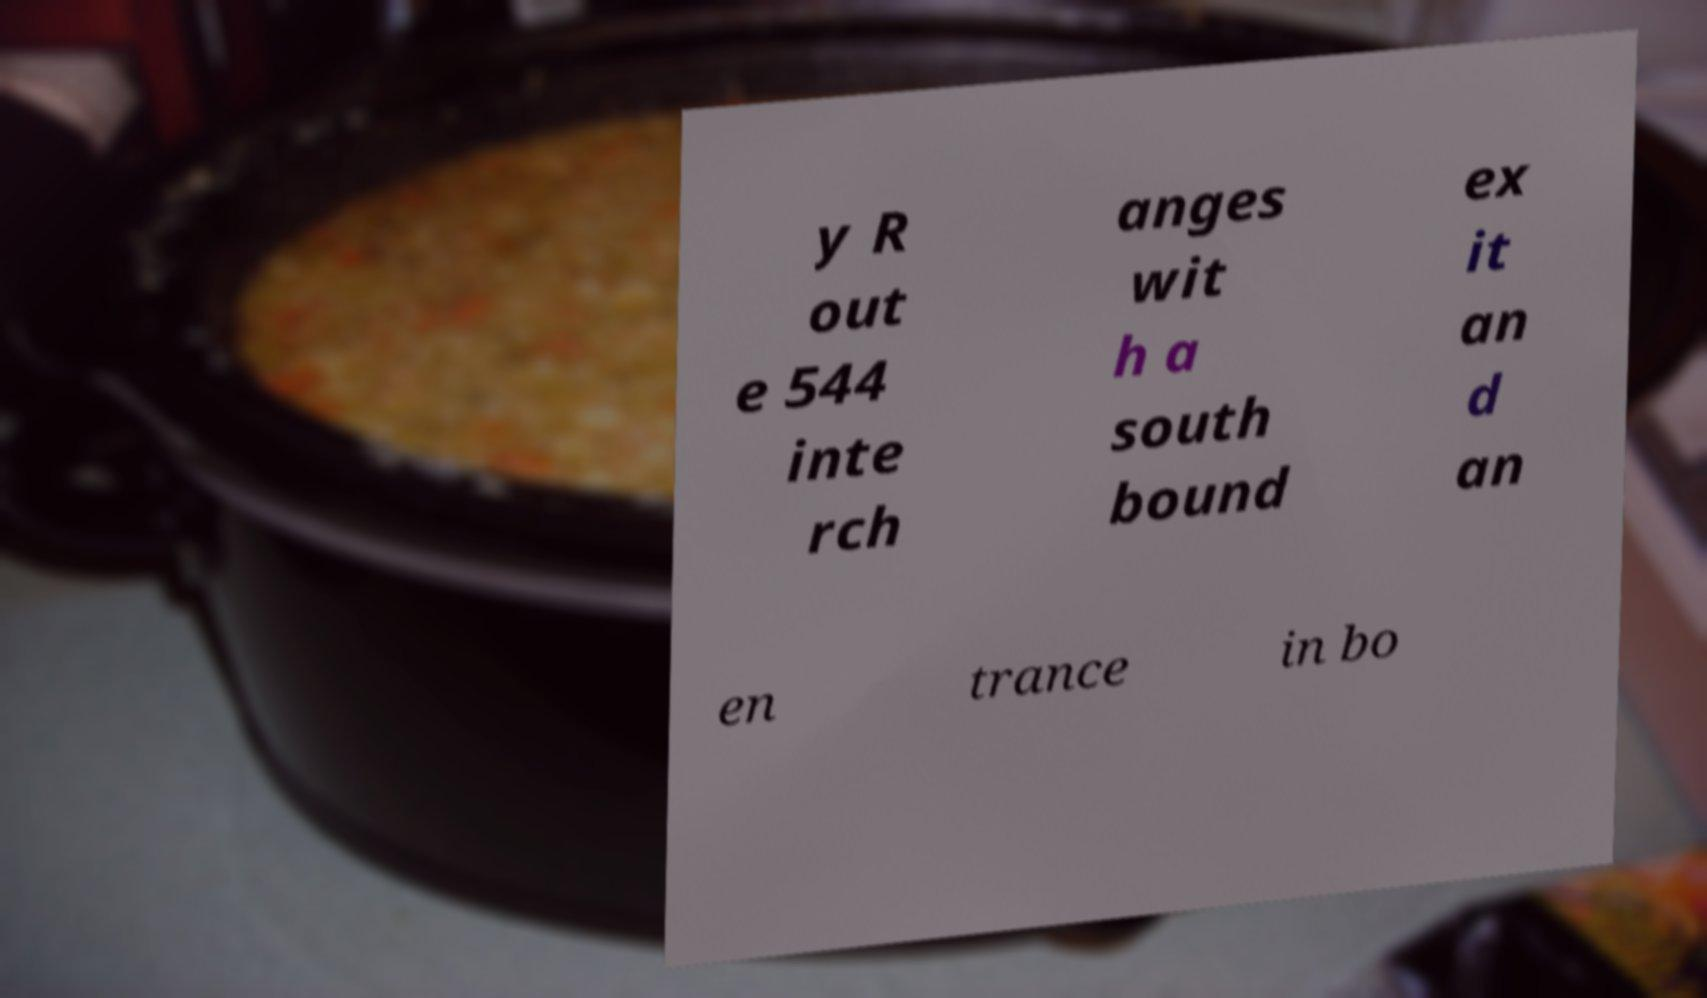Please identify and transcribe the text found in this image. y R out e 544 inte rch anges wit h a south bound ex it an d an en trance in bo 